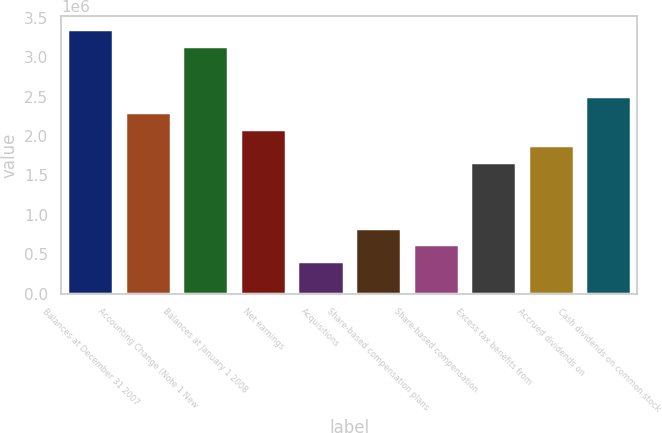Convert chart to OTSL. <chart><loc_0><loc_0><loc_500><loc_500><bar_chart><fcel>Balances at December 31 2007<fcel>Accounting Change (Note 1 New<fcel>Balances at January 1 2008<fcel>Net earnings<fcel>Acquisitions<fcel>Share-based compensation plans<fcel>Share-based compensation<fcel>Excess tax benefits from<fcel>Accrued dividends on<fcel>Cash dividends on common stock<nl><fcel>3.35187e+06<fcel>2.30441e+06<fcel>3.14237e+06<fcel>2.09492e+06<fcel>418984<fcel>837967<fcel>628475<fcel>1.67593e+06<fcel>1.88542e+06<fcel>2.5139e+06<nl></chart> 